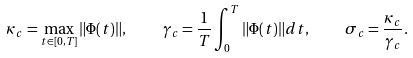<formula> <loc_0><loc_0><loc_500><loc_500>\kappa _ { c } = \max _ { t \in [ 0 , T ] } \| \Phi ( t ) \| , \quad \gamma _ { c } = \frac { 1 } { T } \int _ { 0 } ^ { T } \| \Phi ( t ) \| d t , \quad \sigma _ { c } = \frac { \kappa _ { c } } { \gamma _ { c } } .</formula> 